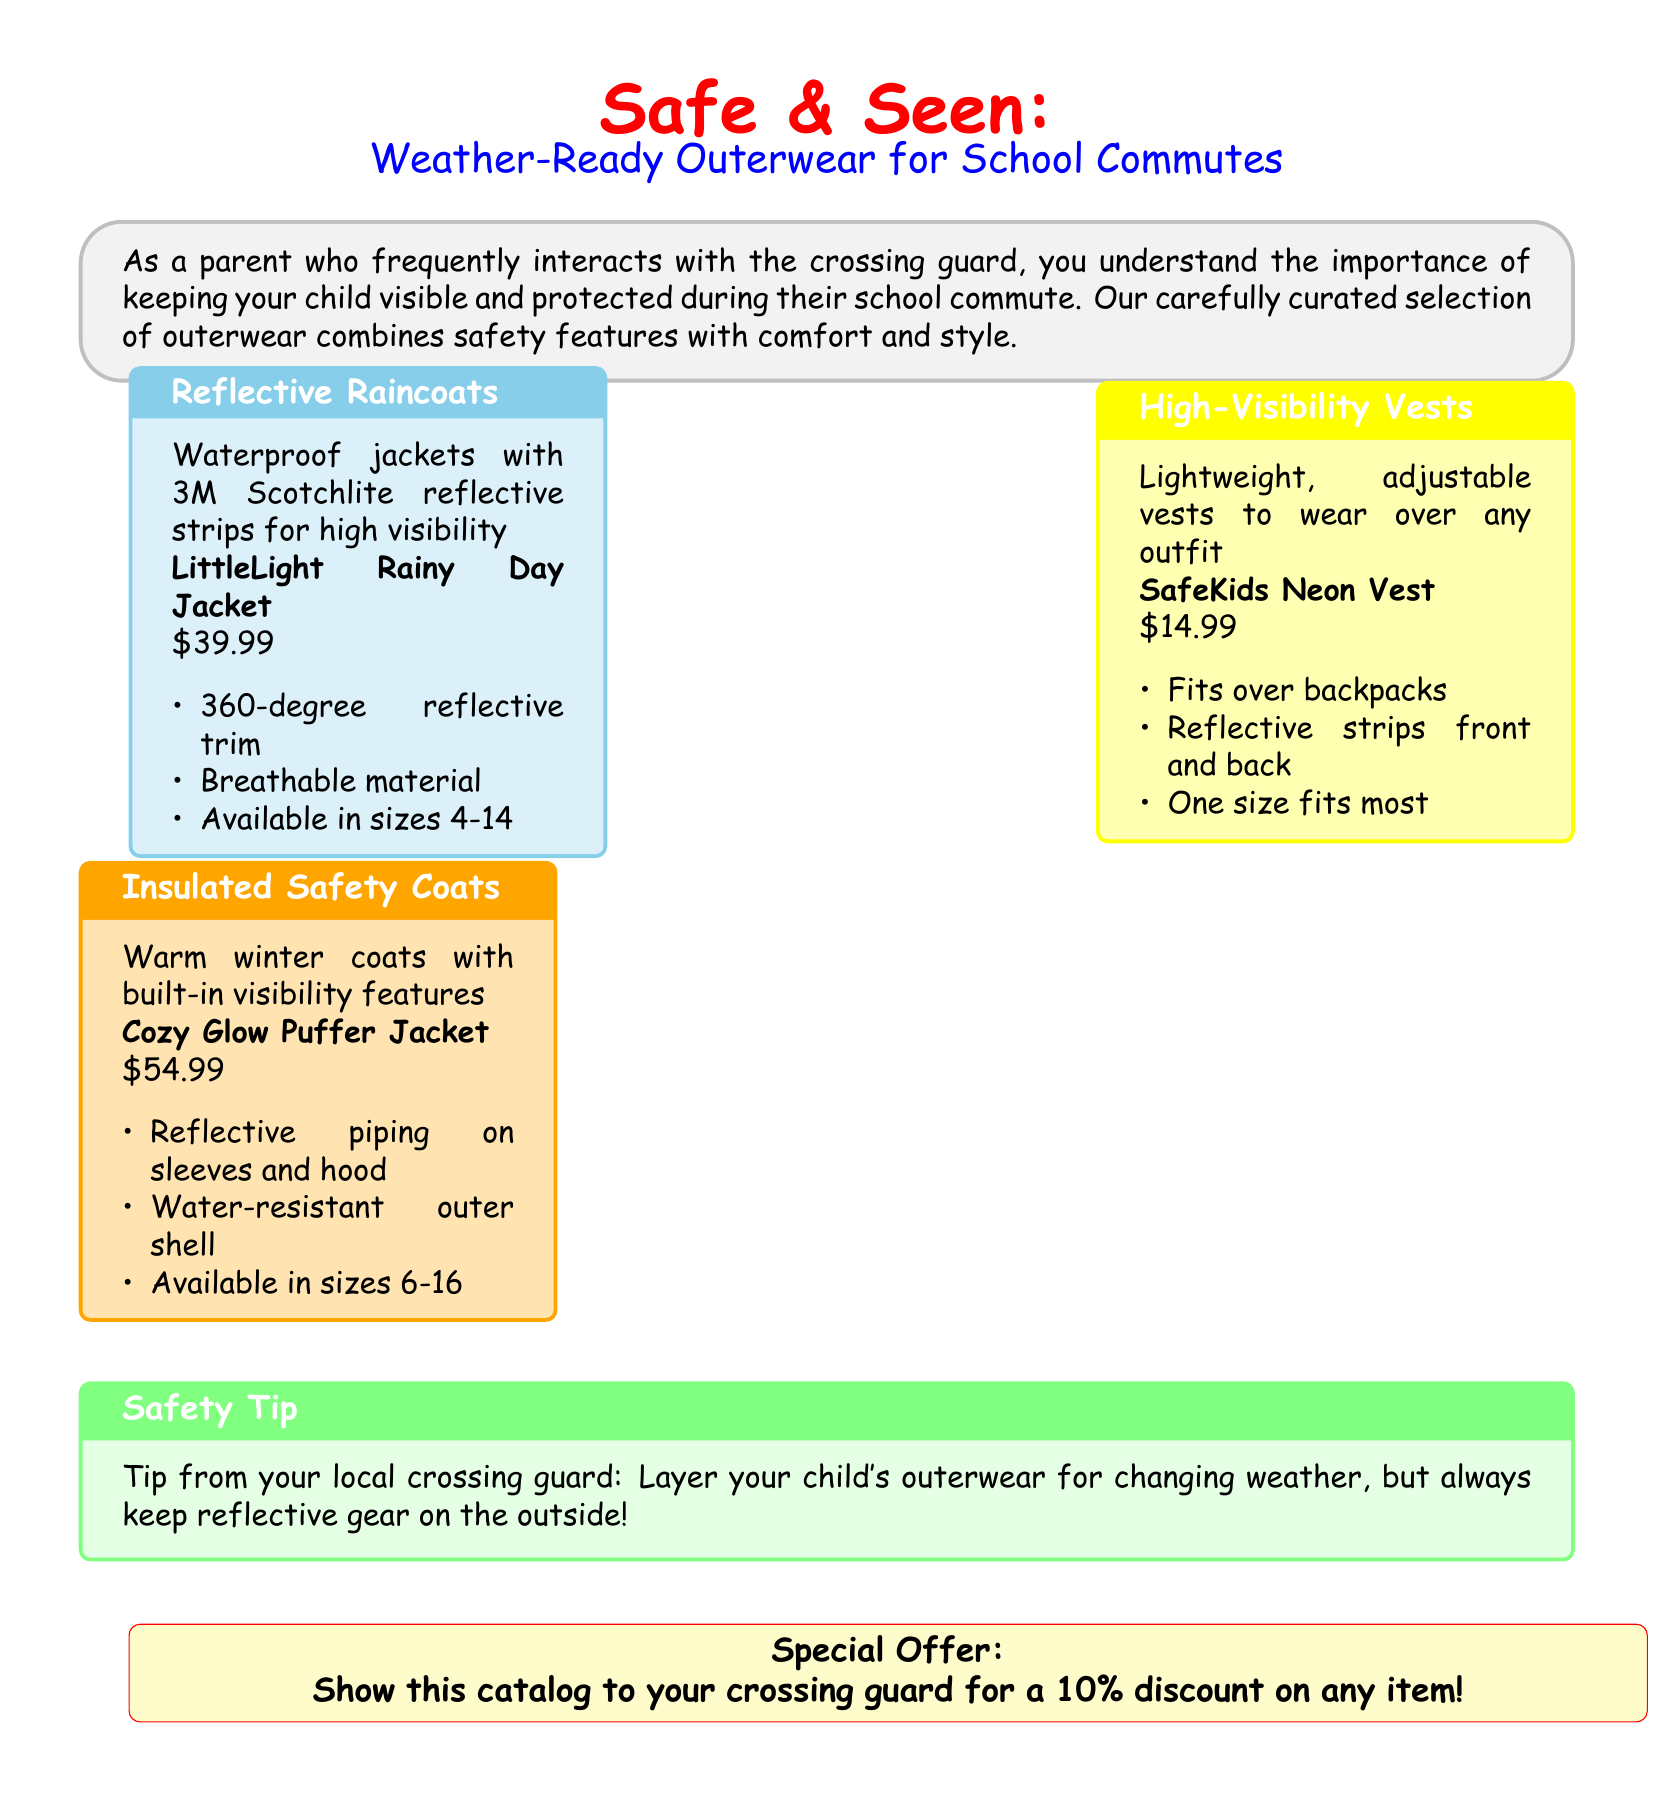What is the price of the LittleLight Rainy Day Jacket? The price is explicitly mentioned in the document under the product details for the LittleLight Rainy Day Jacket.
Answer: $39.99 What type of fabric does the Cozy Glow Puffer Jacket have? The document states that the Cozy Glow Puffer Jacket has a water-resistant outer shell.
Answer: Water-resistant How many sizes are available for the SafeKids Neon Vest? The document states that the SafeKids Neon Vest comes in one size that fits most.
Answer: One size What safety feature is included in the Reflective Raincoats? The document highlights that Reflective Raincoats have 3M Scotchlite reflective strips for visibility.
Answer: Reflective strips What is the special offer mentioned in the catalog? The catalog notes a specific promotion where showing the catalog to the crossing guard will yield a discount.
Answer: 10% discount How should a parent layer their child's outerwear? The safety tip section provides guidance on how to effectively layer outerwear for weather changes.
Answer: Reflective gear on the outside What is the main purpose of these outerwear products? The introduction of the document outlines the purpose of keeping children visible and protected during commutes.
Answer: Visibility and protection What color is the SafeKids Neon Vest? The document specifies that the SafeKids Neon Vest is neon-colored, signifying high visibility.
Answer: Neon What type of coating does the Cozy Glow Puffer Jacket provide? The document states that the Cozy Glow Puffer Jacket is equipped with a water-resistant coating for protection against weather elements.
Answer: Water-resistant 